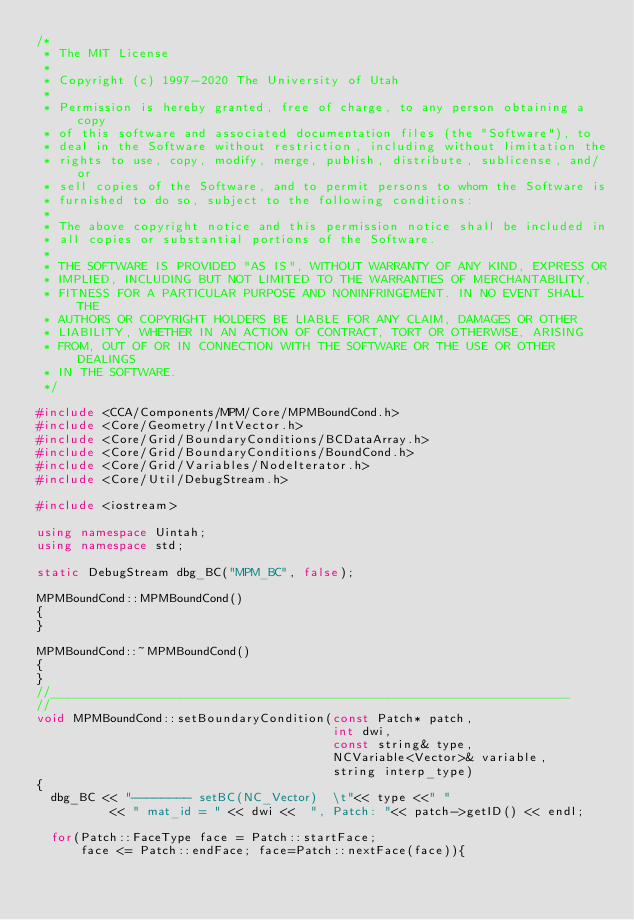<code> <loc_0><loc_0><loc_500><loc_500><_C++_>/*
 * The MIT License
 *
 * Copyright (c) 1997-2020 The University of Utah
 *
 * Permission is hereby granted, free of charge, to any person obtaining a copy
 * of this software and associated documentation files (the "Software"), to
 * deal in the Software without restriction, including without limitation the
 * rights to use, copy, modify, merge, publish, distribute, sublicense, and/or
 * sell copies of the Software, and to permit persons to whom the Software is
 * furnished to do so, subject to the following conditions:
 *
 * The above copyright notice and this permission notice shall be included in
 * all copies or substantial portions of the Software.
 *
 * THE SOFTWARE IS PROVIDED "AS IS", WITHOUT WARRANTY OF ANY KIND, EXPRESS OR
 * IMPLIED, INCLUDING BUT NOT LIMITED TO THE WARRANTIES OF MERCHANTABILITY,
 * FITNESS FOR A PARTICULAR PURPOSE AND NONINFRINGEMENT. IN NO EVENT SHALL THE
 * AUTHORS OR COPYRIGHT HOLDERS BE LIABLE FOR ANY CLAIM, DAMAGES OR OTHER
 * LIABILITY, WHETHER IN AN ACTION OF CONTRACT, TORT OR OTHERWISE, ARISING
 * FROM, OUT OF OR IN CONNECTION WITH THE SOFTWARE OR THE USE OR OTHER DEALINGS
 * IN THE SOFTWARE.
 */

#include <CCA/Components/MPM/Core/MPMBoundCond.h>
#include <Core/Geometry/IntVector.h>
#include <Core/Grid/BoundaryConditions/BCDataArray.h>
#include <Core/Grid/BoundaryConditions/BoundCond.h>
#include <Core/Grid/Variables/NodeIterator.h>
#include <Core/Util/DebugStream.h>

#include <iostream>

using namespace Uintah;
using namespace std;

static DebugStream dbg_BC("MPM_BC", false);

MPMBoundCond::MPMBoundCond()
{
}

MPMBoundCond::~MPMBoundCond()
{
}
//______________________________________________________________________
//
void MPMBoundCond::setBoundaryCondition(const Patch* patch,
                                        int dwi,
                                        const string& type, 
                                        NCVariable<Vector>& variable,
                                        string interp_type)
{
  dbg_BC << "-------- setBC(NC_Vector)  \t"<< type <<" "
          << " mat_id = " << dwi <<  ", Patch: "<< patch->getID() << endl;
          
  for(Patch::FaceType face = Patch::startFace;
      face <= Patch::endFace; face=Patch::nextFace(face)){
      </code> 